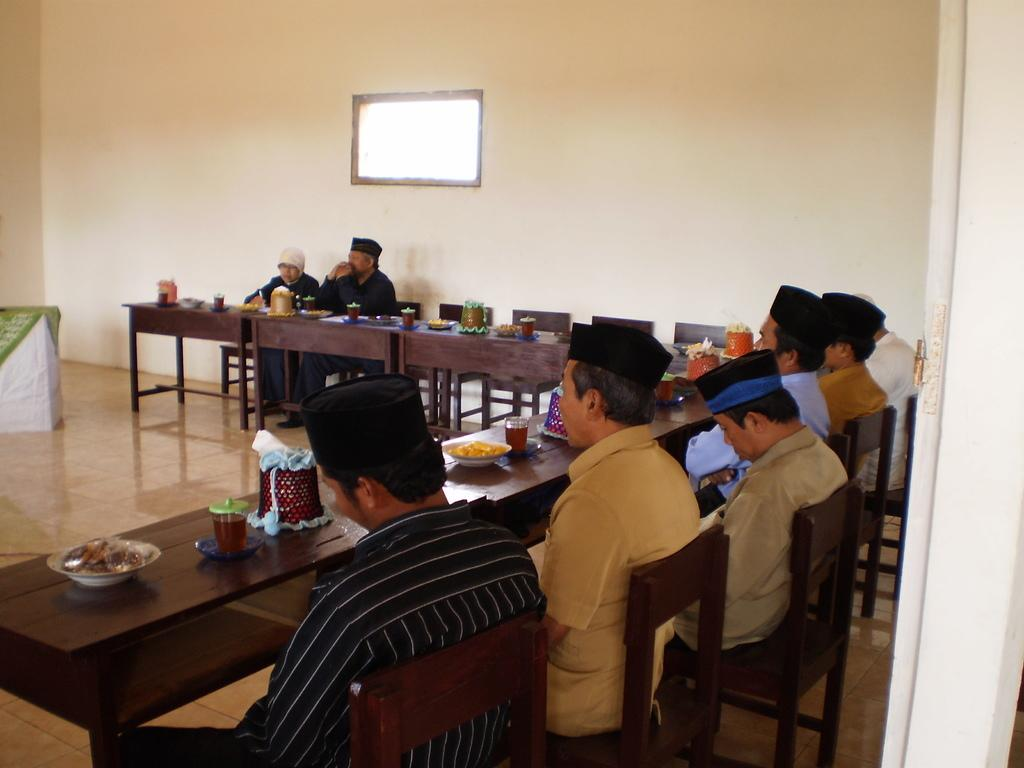What are the men in the image doing? The men are sitting on chairs in the image. Where are the men located in relation to the dining table? The men are in front of a dining table. What can be found on the dining table? There is food, glasses, and bowls on the dining table. What type of fish can be seen swimming in the glasses on the dining table? There are no fish present in the image; the glasses on the dining table are empty or contain a beverage. 